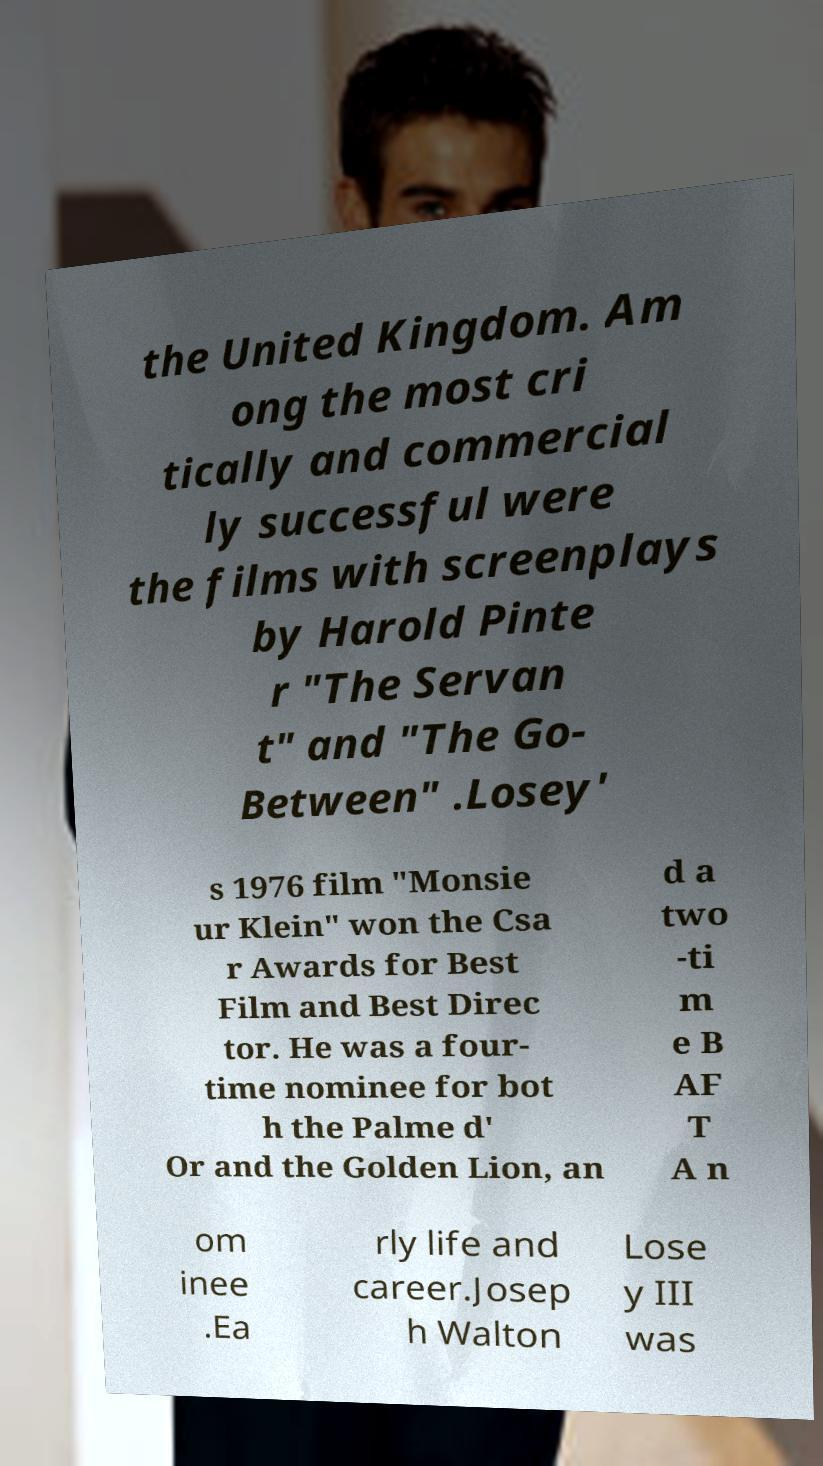Can you read and provide the text displayed in the image?This photo seems to have some interesting text. Can you extract and type it out for me? the United Kingdom. Am ong the most cri tically and commercial ly successful were the films with screenplays by Harold Pinte r "The Servan t" and "The Go- Between" .Losey' s 1976 film "Monsie ur Klein" won the Csa r Awards for Best Film and Best Direc tor. He was a four- time nominee for bot h the Palme d' Or and the Golden Lion, an d a two -ti m e B AF T A n om inee .Ea rly life and career.Josep h Walton Lose y III was 